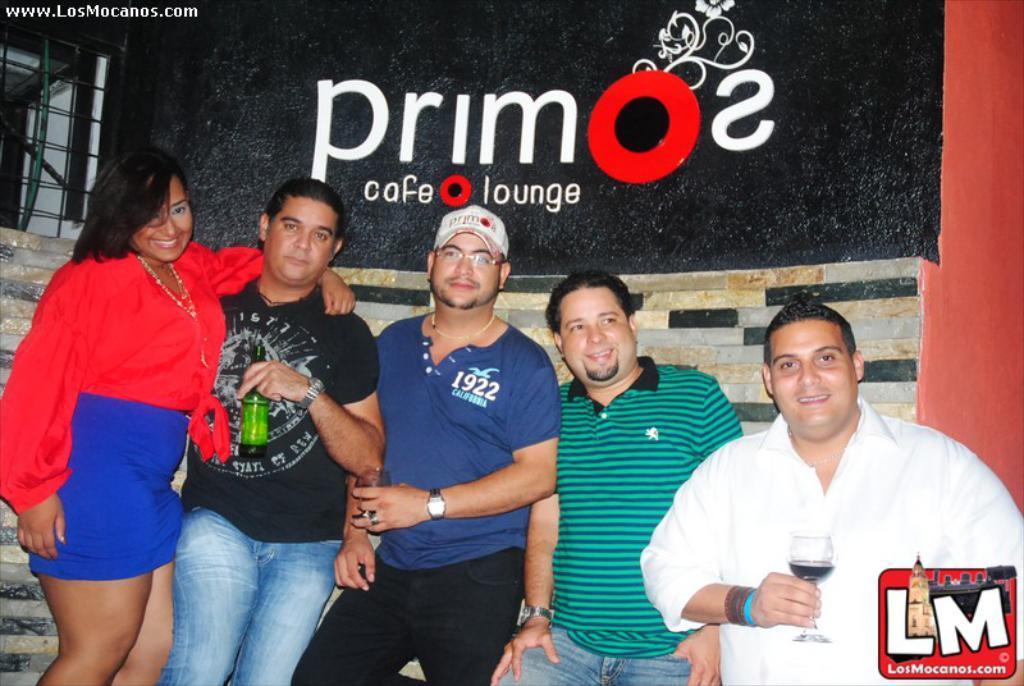How would you summarize this image in a sentence or two? In this picture we can see a group of people standing. A man in the white shirt is holding a glass and another man in the black t shirt is holding a bottle. Behind the people there is a wall and it is written something on it. On the image there are watermarks. 